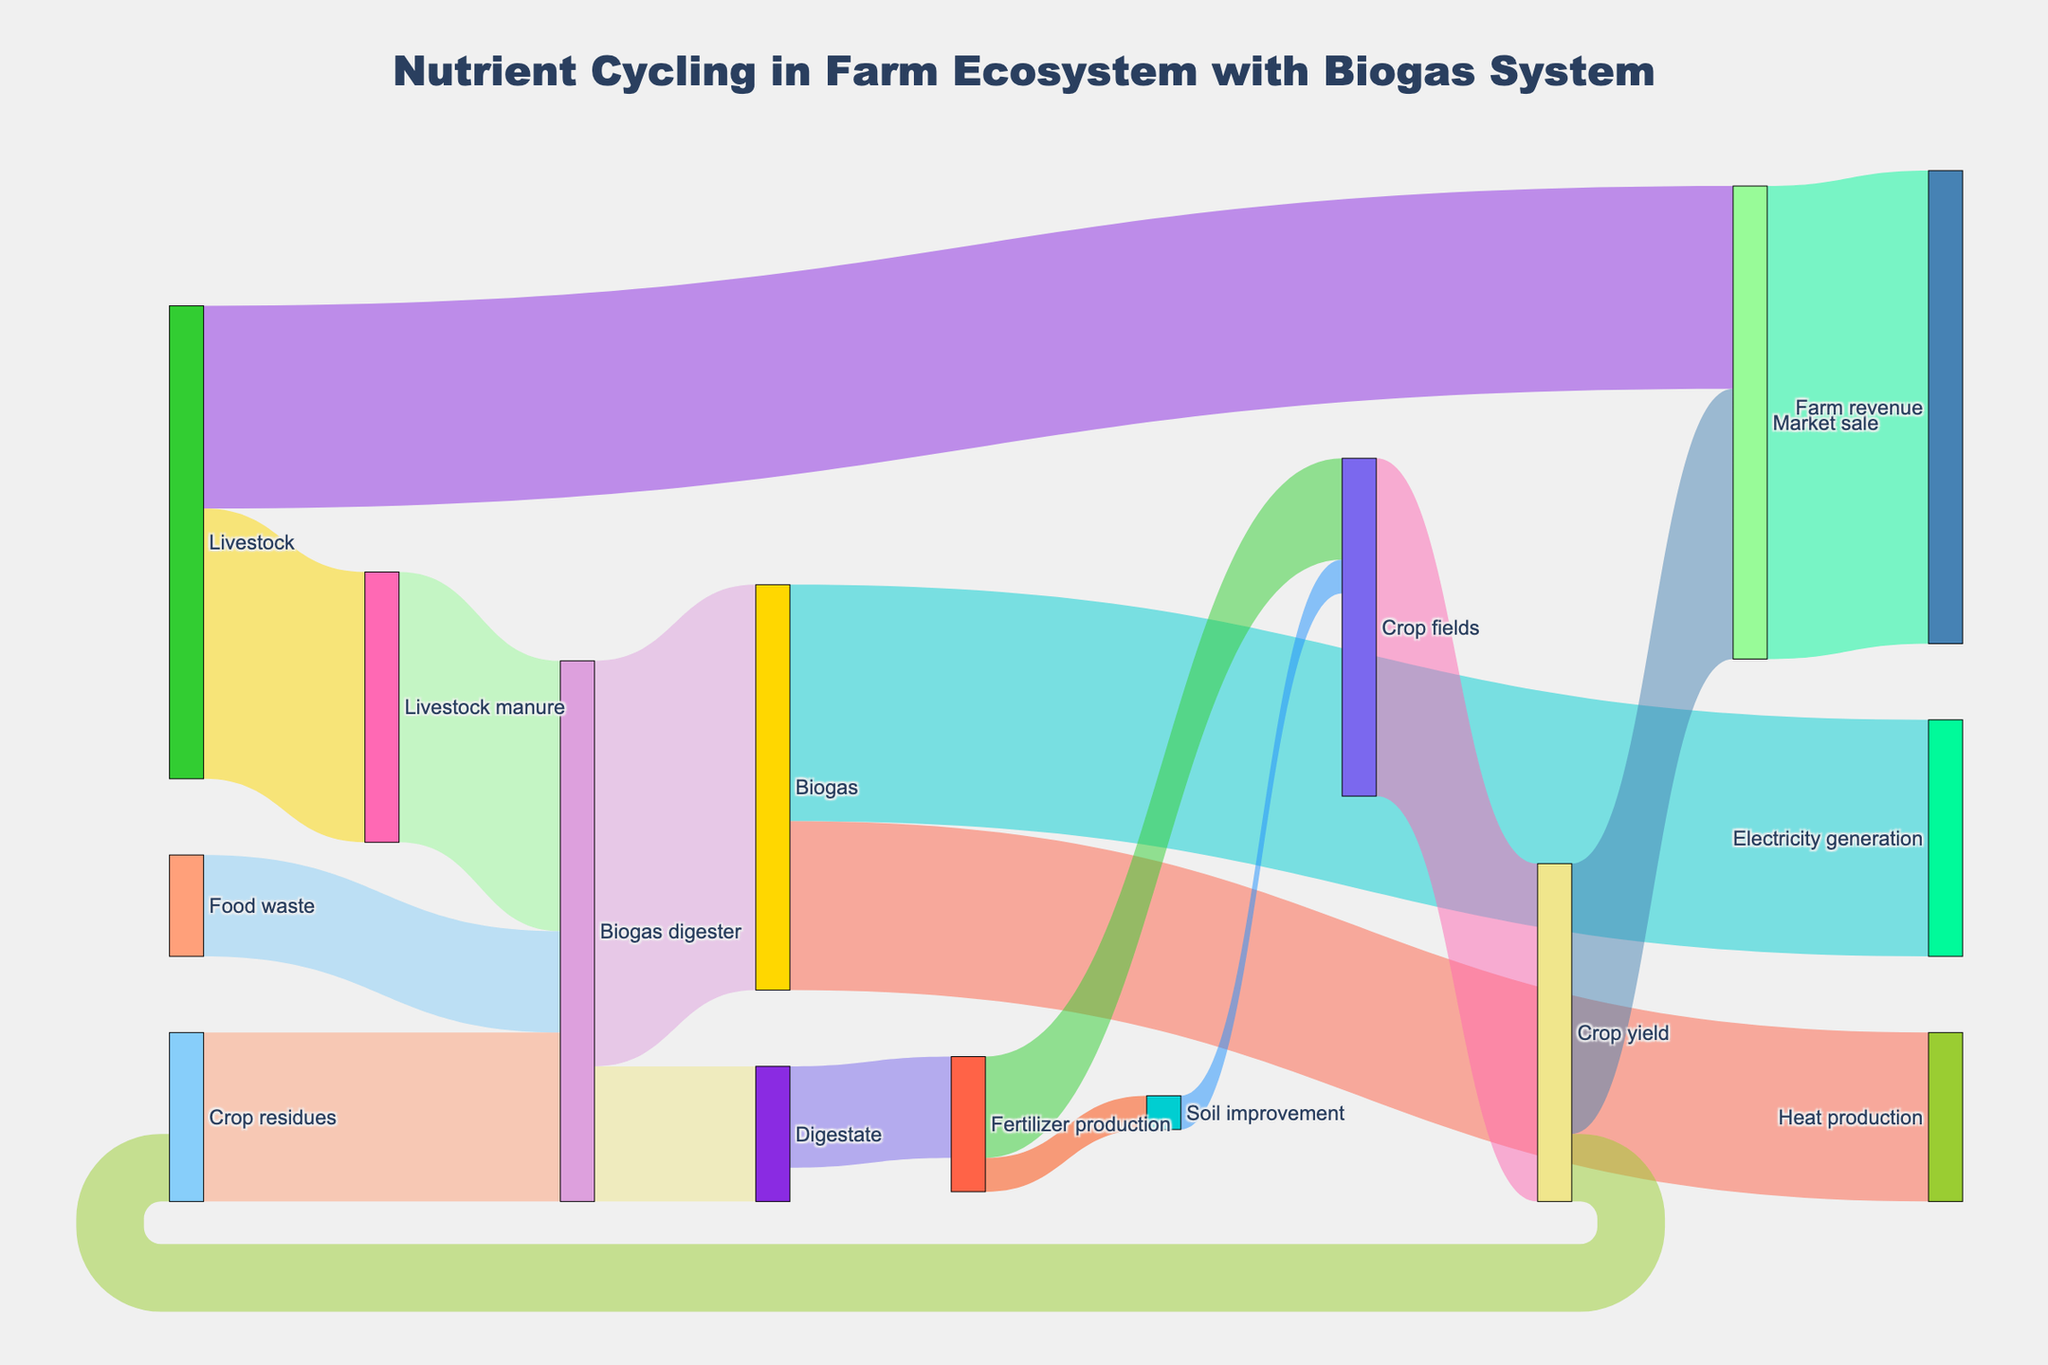What is the title of the figure? The title of the figure is usually placed at the top of the chart. In this case, we can look at the top of the figure to see the title given.
Answer: Nutrient Cycling in Farm Ecosystem with Biogas System What are the main sources feeding into the Biogas digester? In a Sankey diagram, the main sources feeding into a node are the ones directed towards it. By tracing the arrows going to the Biogas digester, we can identify them.
Answer: Crop residues, Livestock manure, Food waste How much energy is generated from Biogas for Electricity generation? To find this value, look at the flow from "Biogas" to "Electricity generation" and check the corresponding number on the arrow.
Answer: 70 How much fertilizer is produced from the Digestate? Follow the flow from "Digestate" to "Fertilizer production" and see the value indicated on the connecting arrow.
Answer: 30 What is the crop yield from Crop fields? Examine the flow from "Crop fields" to "Crop yield" and note down the number provided.
Answer: 100 How much of the Crop yield goes to Market sale? Follow the arrow between "Crop yield" and "Market sale" and read the value presented there.
Answer: 80 What is the total Farm revenue generated from Market sale? Look at the Sankey diagram for the flow from "Market sale" to "Farm revenue" to identify this value.
Answer: 140 What is the combined amount of resources fed into the Biogas digester? Add the values of all arrows flowing into the Biogas digester: Crop residues (50) + Livestock manure (80) + Food waste (30).
Answer: 160 Compare the amount of Biogas used for Electricity generation with that used for Heat production. Identify the values on the arrows from "Biogas" to "Electricity generation" (70) and "Biogas" to "Heat production" (50). Compare these values.
Answer: Electricity generation uses more Biogas than Heat production How does the Digestate contribute to soil improvement and fertilizer production? Follow the arrows from "Digestate" to its targets which are "Fertilizer production" (30) and "Soil improvement" (10) to identify the contributions.
Answer: Fertilizer production: 30, Soil improvement: 10 